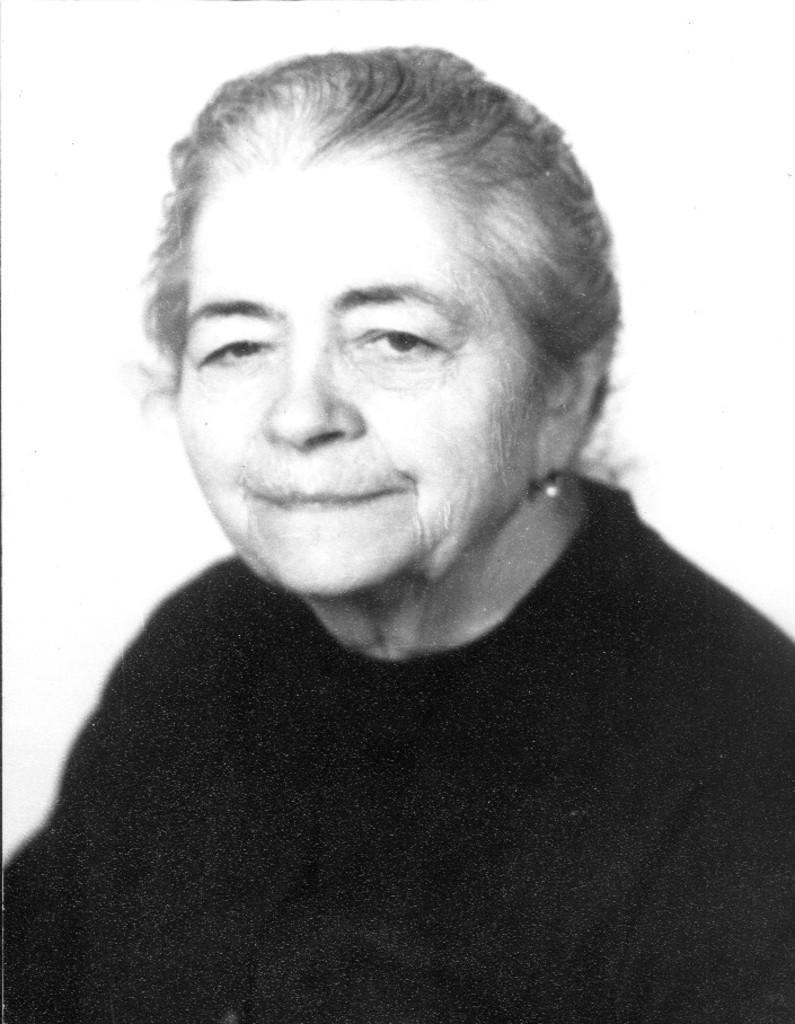Please provide a concise description of this image. This is a black and white image. Here I can see a woman wearing a black dress and looking at the picture. The background is in white color. 